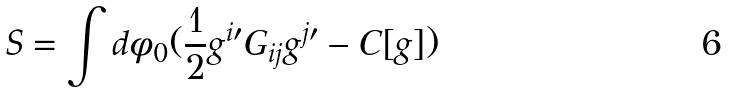<formula> <loc_0><loc_0><loc_500><loc_500>S = \int d \phi _ { 0 } ( \frac { 1 } { 2 } g ^ { i \prime } G _ { i j } g ^ { j \prime } - C [ g ] )</formula> 